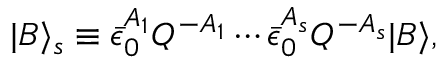<formula> <loc_0><loc_0><loc_500><loc_500>| B \rangle _ { s } \equiv \bar { \epsilon } _ { 0 } ^ { A _ { 1 } } Q ^ { - A _ { 1 } } \cdots \bar { \epsilon } _ { 0 } ^ { A _ { s } } Q ^ { - A _ { s } } | B \rangle ,</formula> 